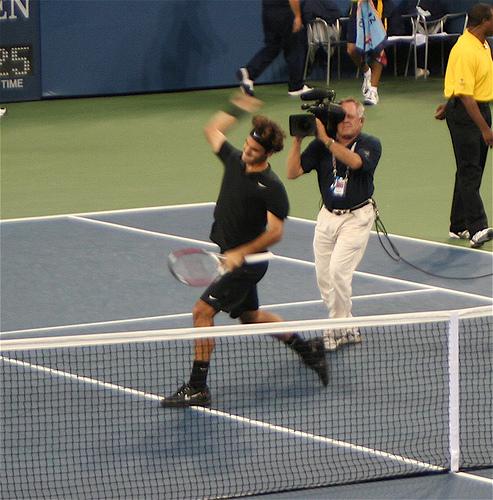Is that a net?
Quick response, please. Yes. What sport is being played in this scene?
Answer briefly. Tennis. Is the player male or female?
Short answer required. Male. What are they wearing?
Be succinct. Clothes. Is the man about to serve?
Write a very short answer. Yes. 